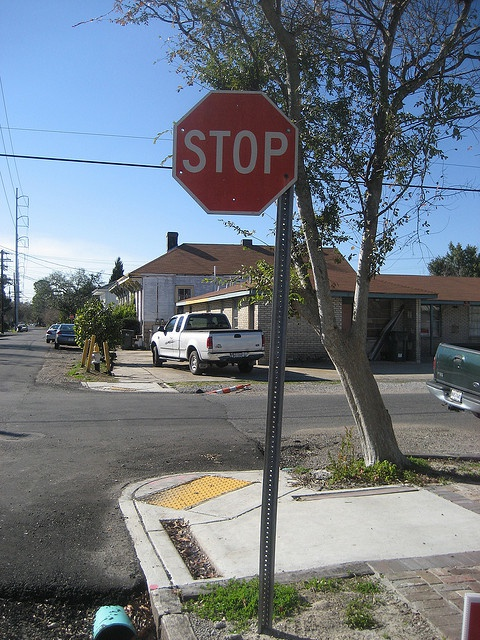Describe the objects in this image and their specific colors. I can see stop sign in lightblue, maroon, gray, purple, and black tones, truck in lightblue, black, lightgray, and gray tones, truck in lightblue, gray, black, purple, and darkgray tones, car in lightblue, black, blue, navy, and gray tones, and car in lightblue, black, gray, darkgray, and blue tones in this image. 